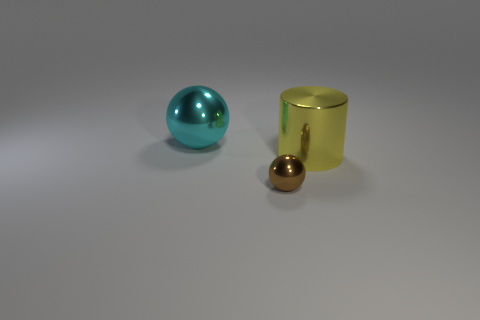There is a thing that is both to the left of the big yellow thing and behind the tiny metal ball; how big is it?
Offer a terse response. Large. How many other objects have the same size as the yellow metallic object?
Offer a very short reply. 1. Does the metallic thing in front of the large metal cylinder have the same shape as the big yellow thing?
Provide a short and direct response. No. Is the number of shiny objects that are right of the brown metal sphere less than the number of yellow cubes?
Offer a very short reply. No. Do the tiny metallic thing and the shiny thing that is to the right of the brown ball have the same shape?
Give a very brief answer. No. Are there any cyan spheres that have the same material as the small brown ball?
Provide a succinct answer. Yes. Are there any tiny metal things left of the metal cylinder that is in front of the big object on the left side of the small brown sphere?
Offer a terse response. Yes. What number of other objects are the same shape as the big yellow metallic object?
Provide a succinct answer. 0. There is a big metal object behind the big object that is in front of the large shiny object on the left side of the tiny brown metal ball; what is its color?
Offer a very short reply. Cyan. How many big brown shiny cubes are there?
Offer a terse response. 0. 